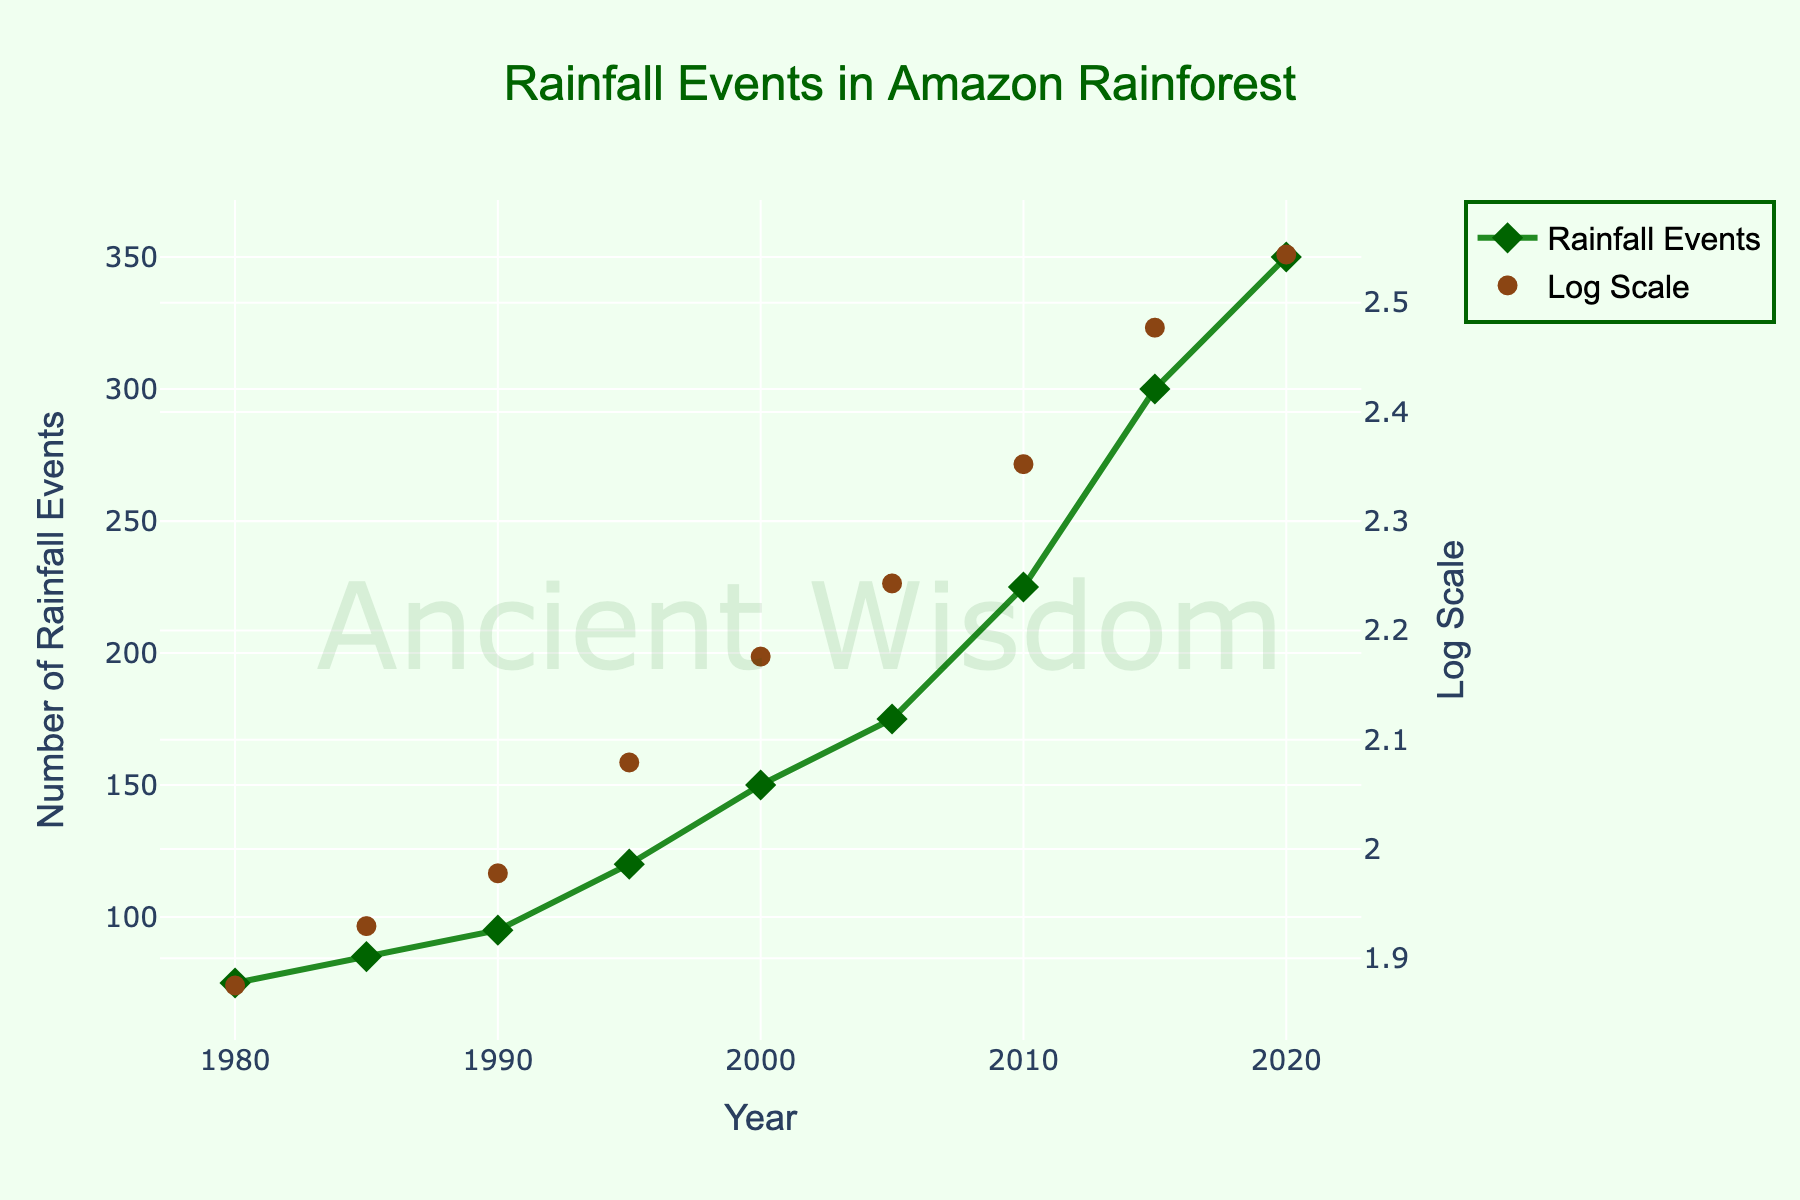What's the title of the figure? The title of the figure is usually placed at the top and easily identifiable because it is typically in larger, bold text.
Answer: Rainfall Events in Amazon Rainforest How many data points are there in the plot? By counting the markers on the plot, each represents a data point corresponding to different years.
Answer: 9 What is the trend in the number of rainfall events from 1980 to 2020? Observe the markers and line pattern. The number of rainfall events increases steadily over time from 1980 to 2020.
Answer: Increasing Which year has the highest frequency of rainfall events? Identify the data point with the highest value on the y-axis. The year 2020 has the highest frequency with 350 events.
Answer: 2020 By how much did the number of rainfall events increase from 2000 to 2010? Subtract the number of events in 2000 (150) from the number of events in 2010 (225).
Answer: 75 What does the log scale represent on the figure? The log scale helps in visualizing data that spans several orders of magnitude. It is plotted on a secondary y-axis for better comparison.
Answer: Log scale of EventCount Compare the rainfall events between 1980 and 1995. Look at the number of events in 1980 (75) and in 1995 (120) and find which year had more events.
Answer: 1995 Is the increase in the number of rainfall events between 1985 and 1990 notable? Calculate the difference: 95 (1990) - 85 (1985) = 10. This is a small increase compared to other intervals.
Answer: No At which intervals did the rainfall events see the highest relative increase based on the log scale highlights? Compare the sizes of steps between data points on the log scale marks. The largest relative increases are seen between 2005 (175) to 2010 (225) and from 2015 (300) to 2020 (350).
Answer: 2005-2010 and 2015-2020 How does the visualization use colors to differentiate data? The plot uses different colors for different elements: a green line and diamond markers for event counts, and brown circle markers for the log scale.
Answer: Green and Brown 